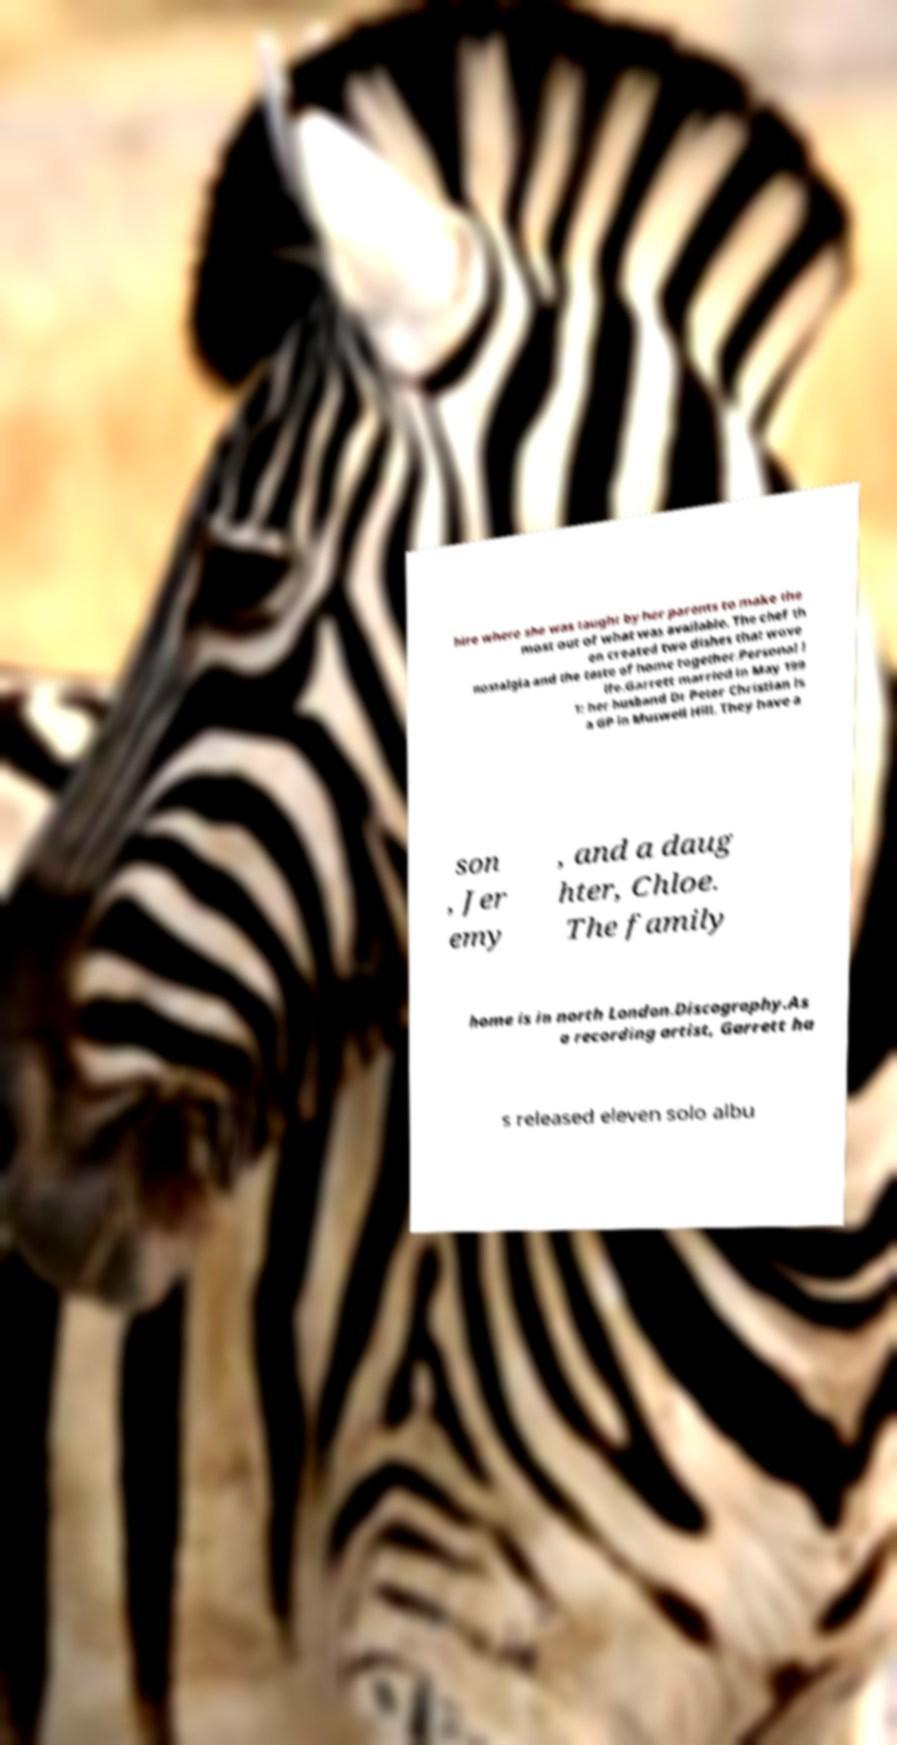Can you accurately transcribe the text from the provided image for me? hire where she was taught by her parents to make the most out of what was available. The chef th en created two dishes that wove nostalgia and the taste of home together.Personal l ife.Garrett married in May 199 1: her husband Dr Peter Christian is a GP in Muswell Hill. They have a son , Jer emy , and a daug hter, Chloe. The family home is in north London.Discography.As a recording artist, Garrett ha s released eleven solo albu 